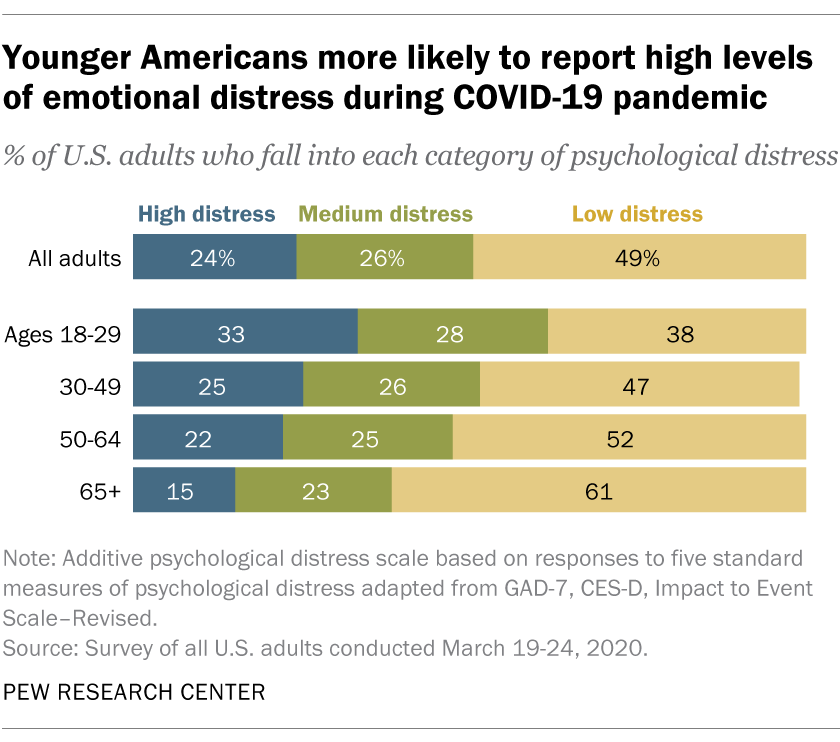Point out several critical features in this image. The age group with the highest percentage of high stress is 30%, and it is composed of individuals between 18 and 29 years old. The age group of 30-49 has a lower sum value than the 50-64 age group. 